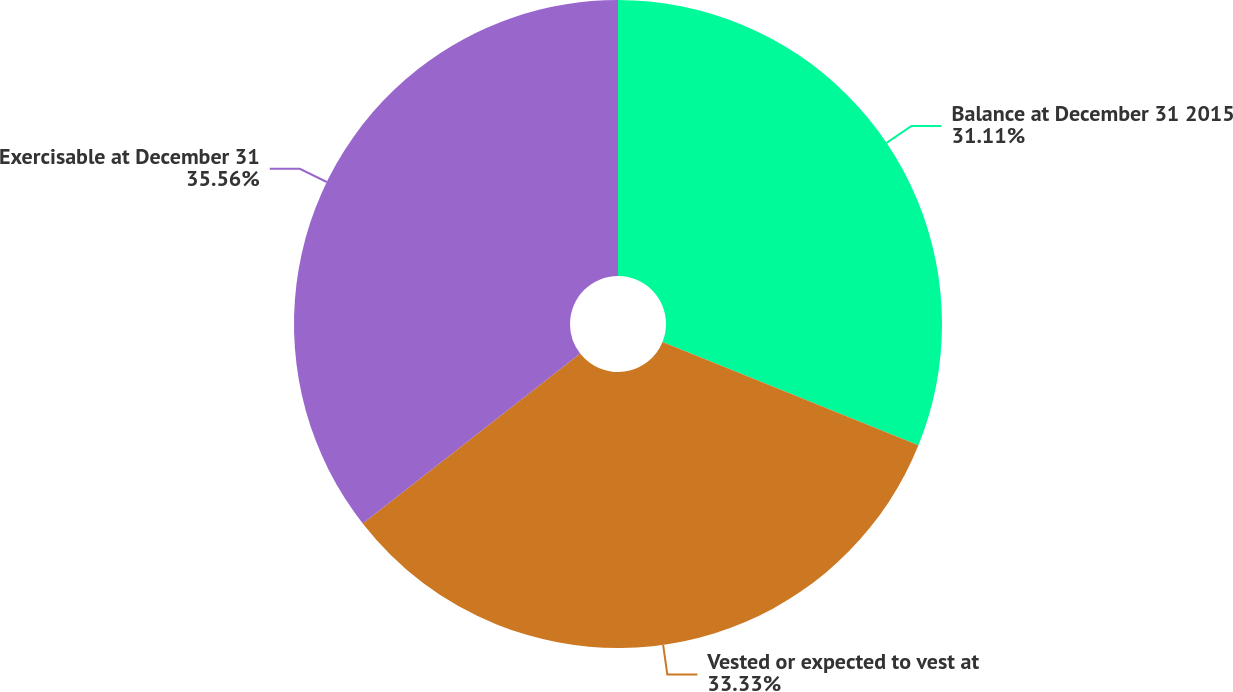Convert chart. <chart><loc_0><loc_0><loc_500><loc_500><pie_chart><fcel>Balance at December 31 2015<fcel>Vested or expected to vest at<fcel>Exercisable at December 31<nl><fcel>31.11%<fcel>33.33%<fcel>35.56%<nl></chart> 